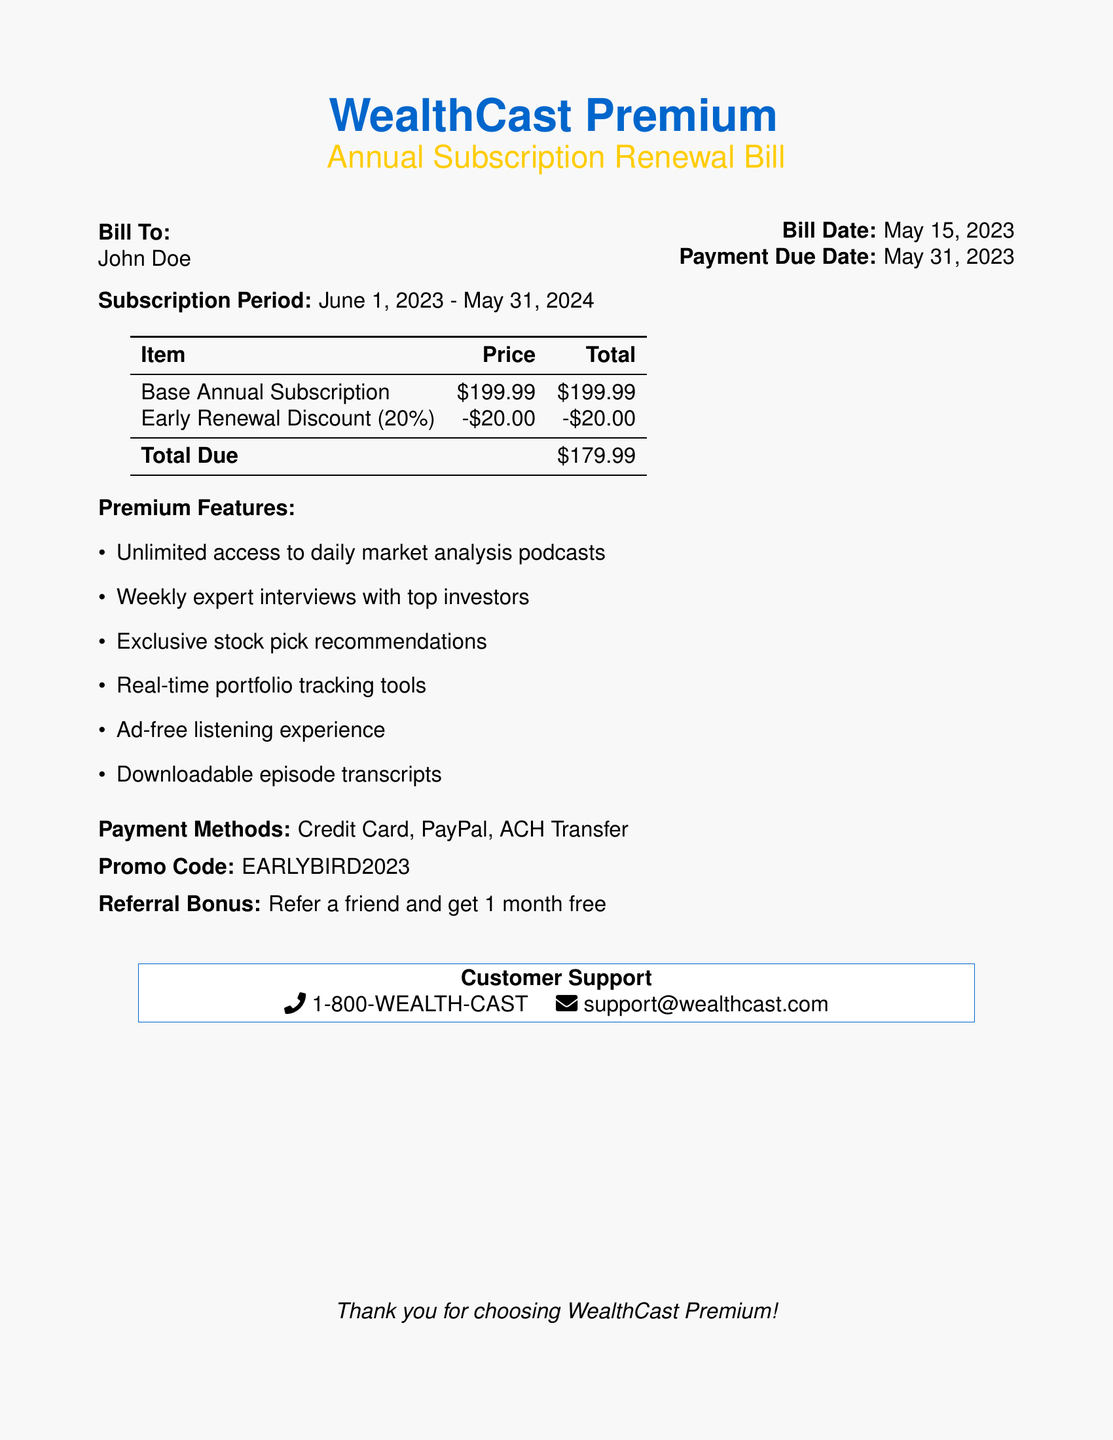What is the bill date? The bill date is specified in the document under the billing information section.
Answer: May 15, 2023 What is the total due after applying the early renewal discount? The total due is calculated by subtracting the early renewal discount from the base annual subscription fee.
Answer: $179.99 What percentage is the early renewal discount? The document specifies the discount percentage applied to the subscription cost.
Answer: 20% What is one premium feature included in the subscription? The document lists several premium features available to subscribers.
Answer: Unlimited access to daily market analysis podcasts What is the subscription period? The subscription period is indicated in the document and defines the duration of the subscription service.
Answer: June 1, 2023 - May 31, 2024 What is the customer support phone number? The phone number for customer support is provided in the final section of the document for ease of contact.
Answer: 1-800-WEALTH-CAST What payment methods are accepted? The document lists the payment methods available for the subscription renewal.
Answer: Credit Card, PayPal, ACH Transfer How long is the referral bonus valid for? The document mentions a referral bonus but does not specify a time limit for validity; this may require further inquiry.
Answer: 1 month free 